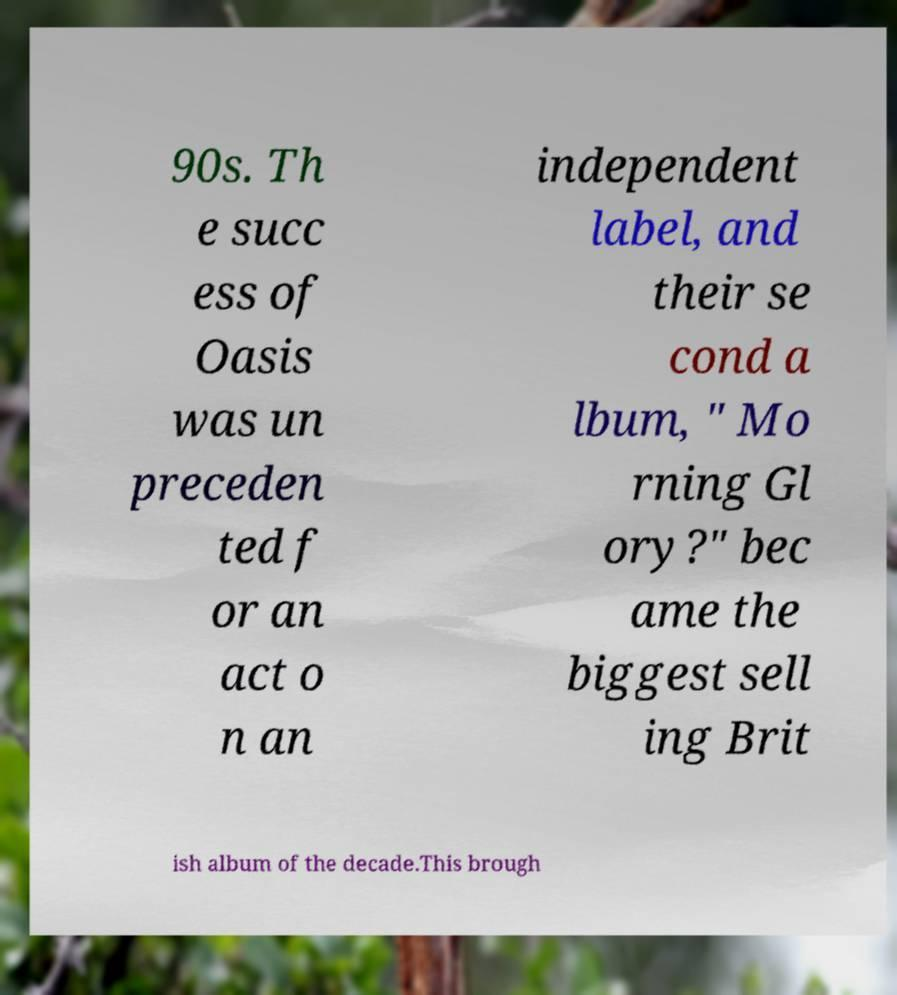Can you read and provide the text displayed in the image?This photo seems to have some interesting text. Can you extract and type it out for me? 90s. Th e succ ess of Oasis was un preceden ted f or an act o n an independent label, and their se cond a lbum, " Mo rning Gl ory?" bec ame the biggest sell ing Brit ish album of the decade.This brough 